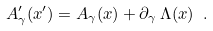<formula> <loc_0><loc_0><loc_500><loc_500>A ^ { \prime } _ { \gamma } ( x ^ { \prime } ) = A _ { \gamma } ( x ) + \partial _ { \gamma } \, \Lambda ( x ) \ .</formula> 